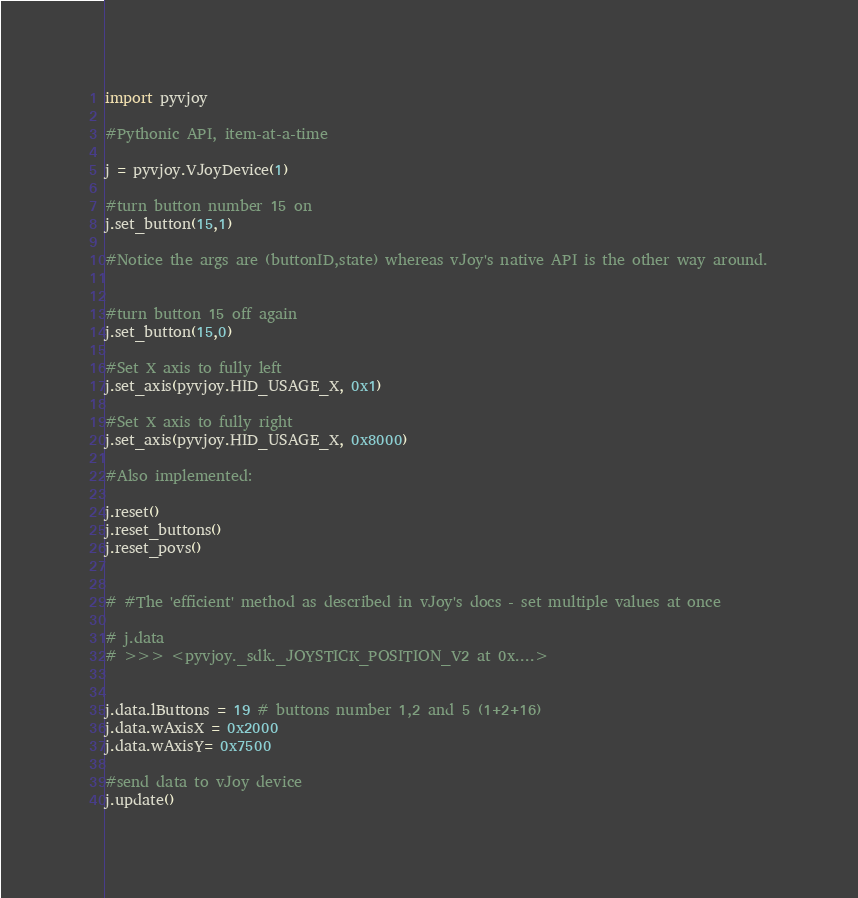<code> <loc_0><loc_0><loc_500><loc_500><_Python_>import pyvjoy

#Pythonic API, item-at-a-time

j = pyvjoy.VJoyDevice(1)

#turn button number 15 on
j.set_button(15,1)

#Notice the args are (buttonID,state) whereas vJoy's native API is the other way around.


#turn button 15 off again
j.set_button(15,0)

#Set X axis to fully left
j.set_axis(pyvjoy.HID_USAGE_X, 0x1)

#Set X axis to fully right
j.set_axis(pyvjoy.HID_USAGE_X, 0x8000)

#Also implemented:

j.reset()
j.reset_buttons()
j.reset_povs()


# #The 'efficient' method as described in vJoy's docs - set multiple values at once

# j.data
# >>> <pyvjoy._sdk._JOYSTICK_POSITION_V2 at 0x....>


j.data.lButtons = 19 # buttons number 1,2 and 5 (1+2+16)
j.data.wAxisX = 0x2000 
j.data.wAxisY= 0x7500

#send data to vJoy device
j.update()


</code> 